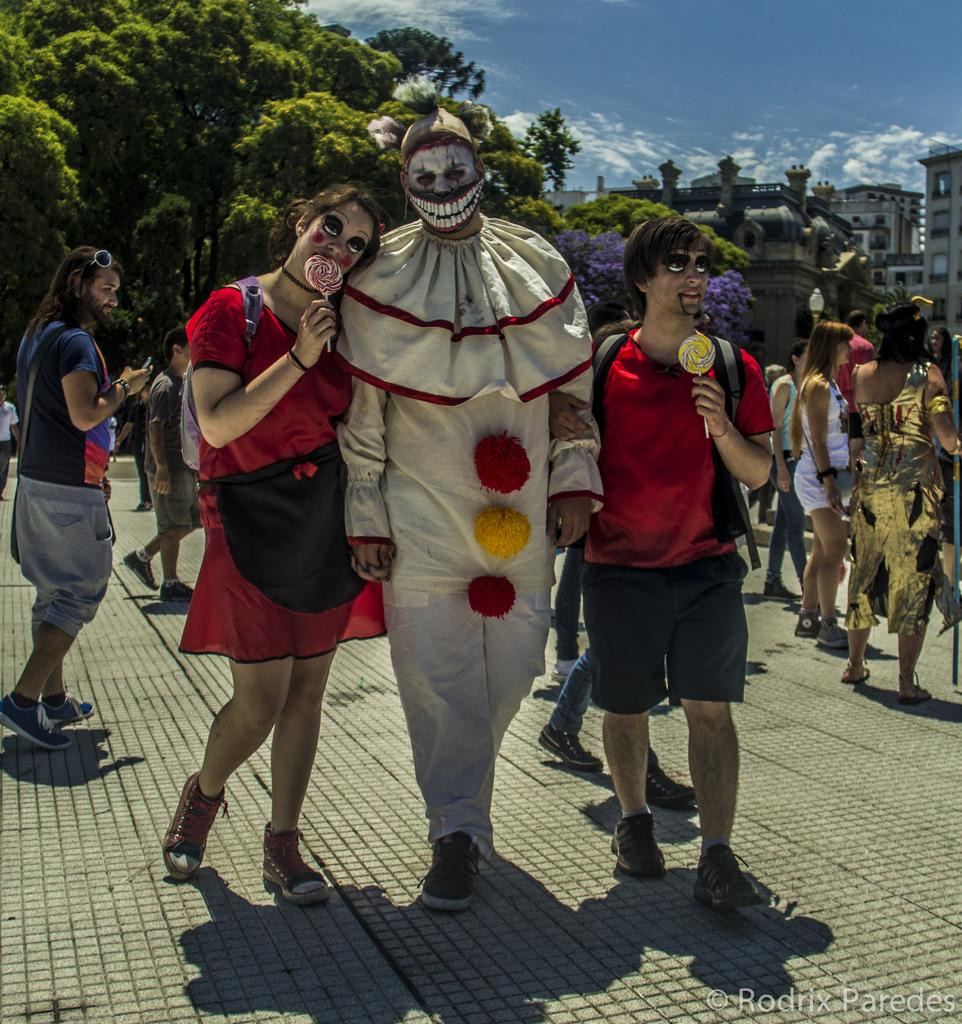What are the people in the image doing? The people in the image are standing and walking. What can be observed about the people's attire? The people are in different costumes. What is the main feature of the image's foreground? There is a path in the image. What can be seen in the background of the image? There are trees and buildings in the background of the image. What flavor of ice cream do the people in the image prefer? There is no mention of ice cream or any flavor preferences in the image. 